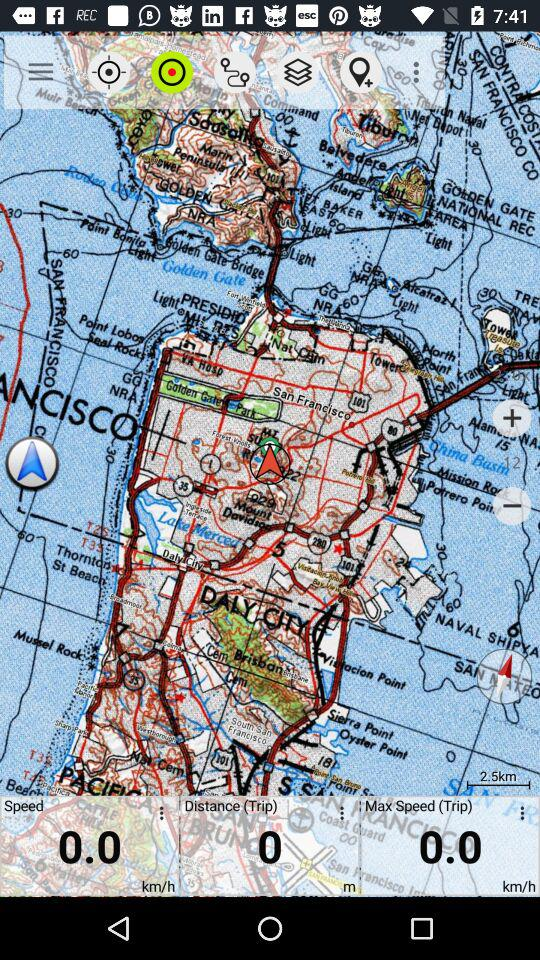What is the speed? The speed is 0.0 km/h. 